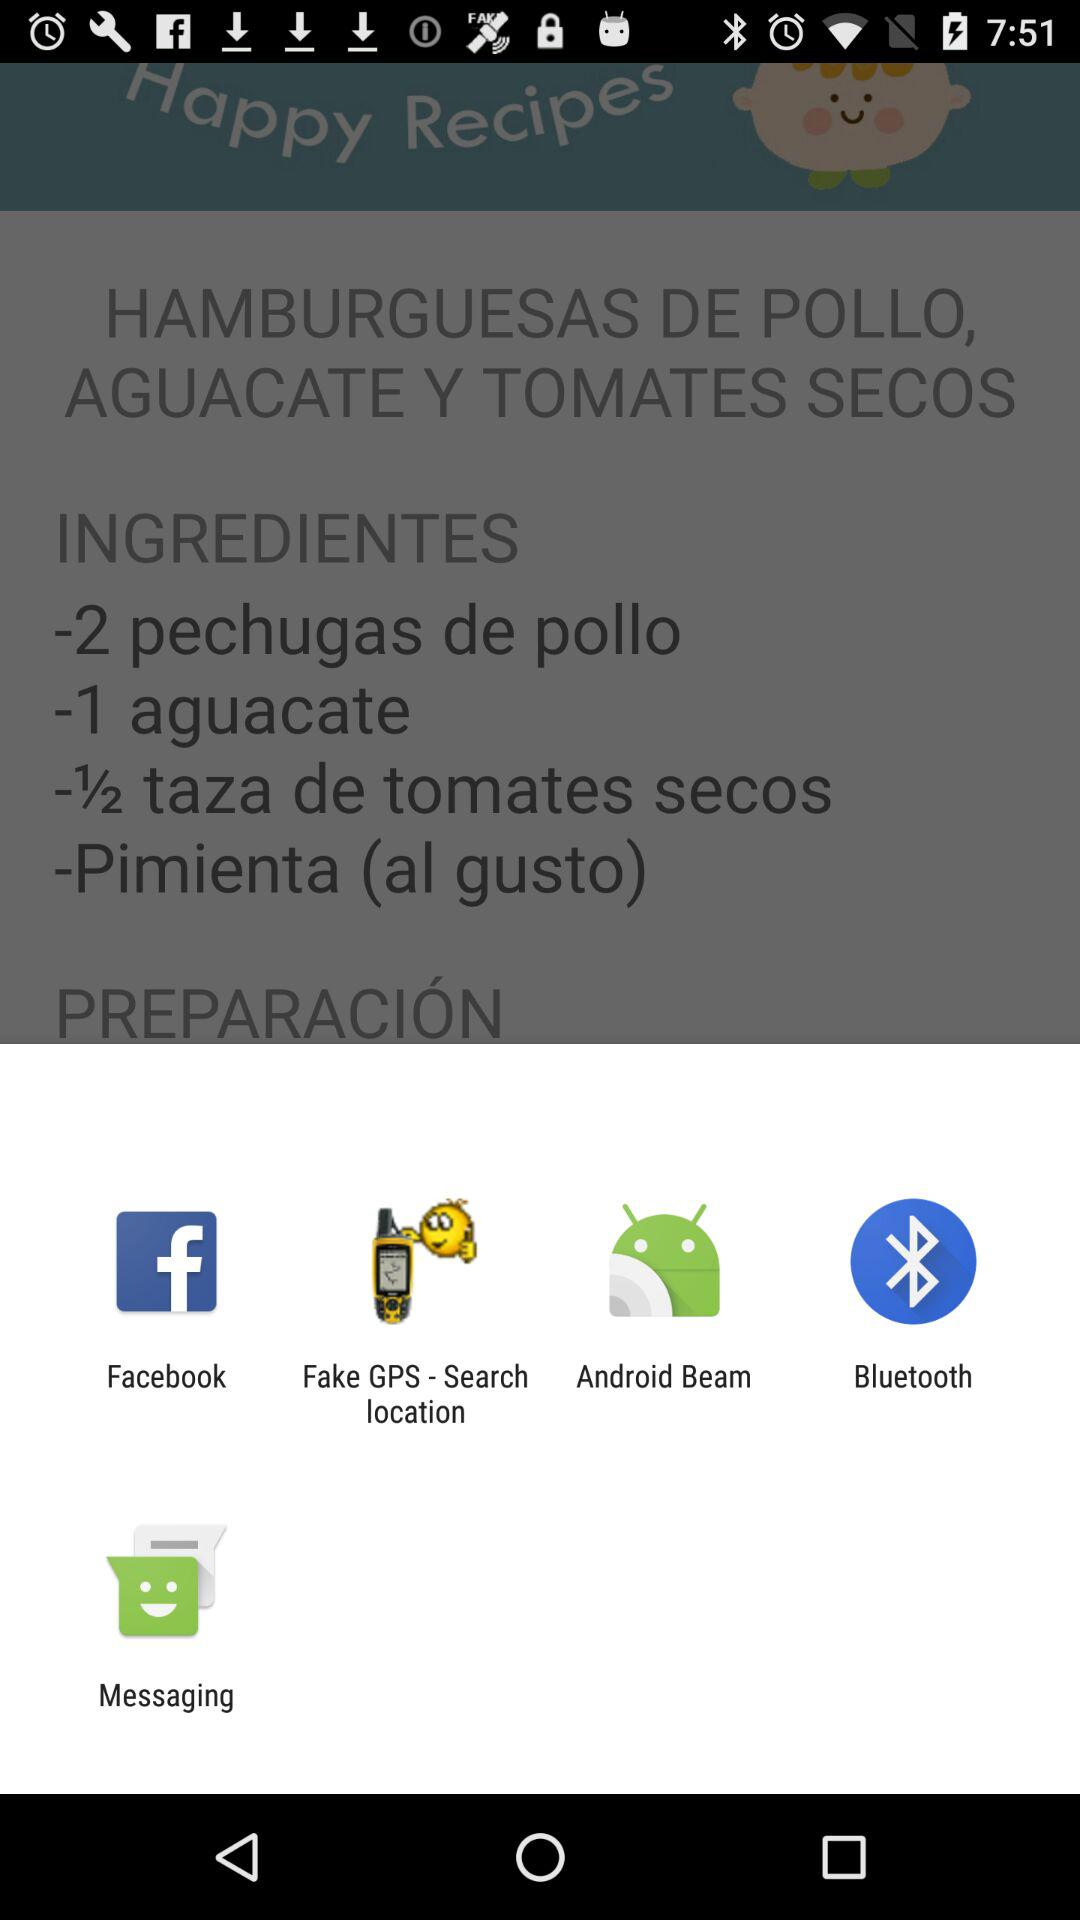Which applications are given? The given applications are "Facebook", "Fake GPS - Search location", "Android Beam", "Bluetooth" and "Messaging". 